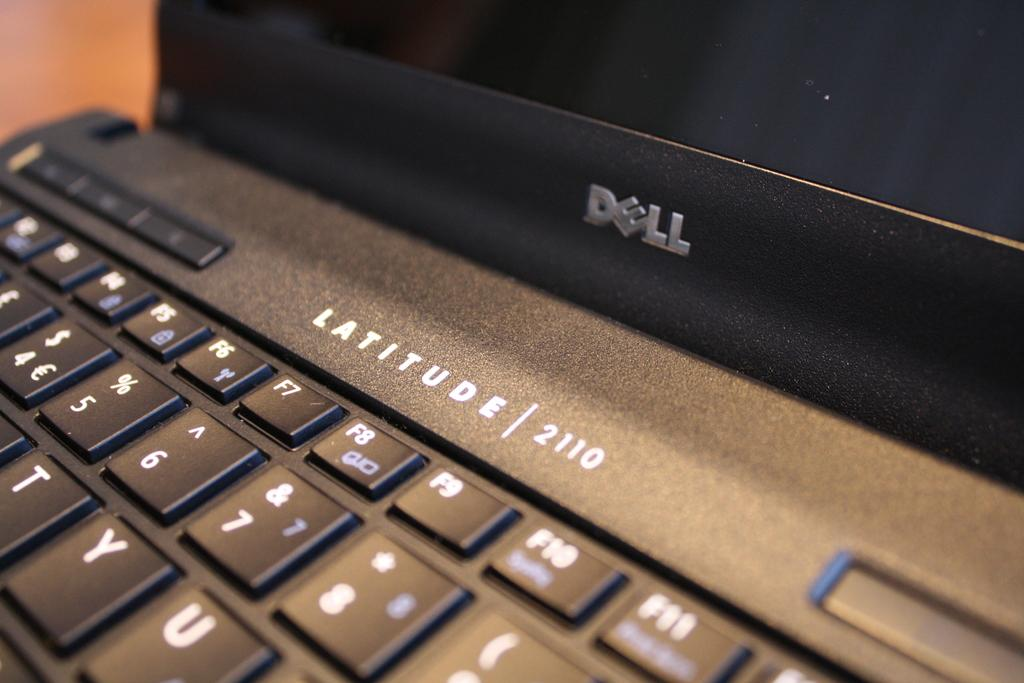<image>
Offer a succinct explanation of the picture presented. A close up of a black Dell Latitude laptop. 